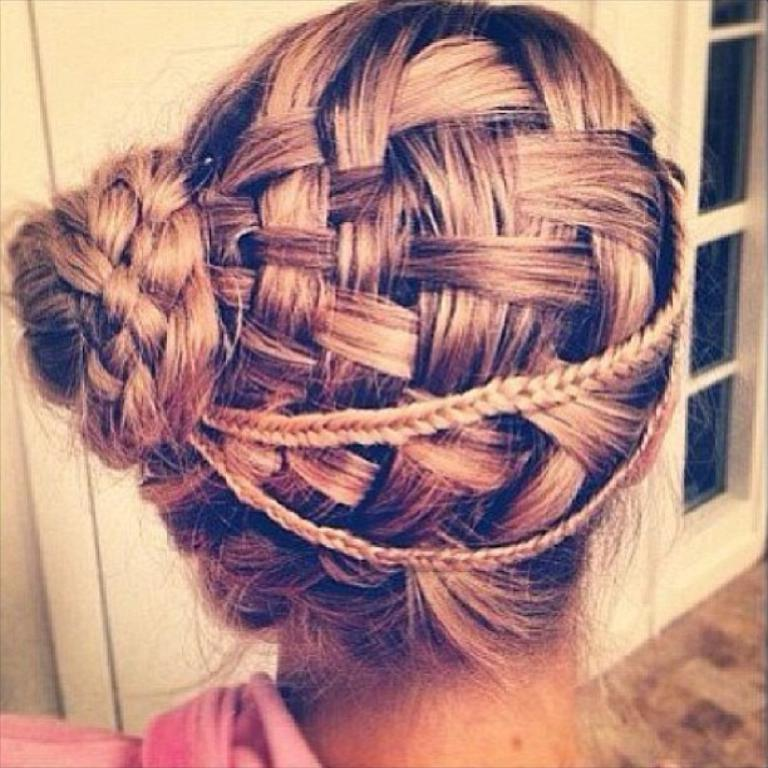Who or what is present in the image? There is a person in the image. What can be seen in the background of the image? There is a wall in the background of the image. What type of architectural feature is visible in the image? There is a glass window in the image. What is the surface on which the person is standing or sitting? There is a floor at the bottom of the image. What type of popcorn is being served by the band in the image? There is no band or popcorn present in the image. 